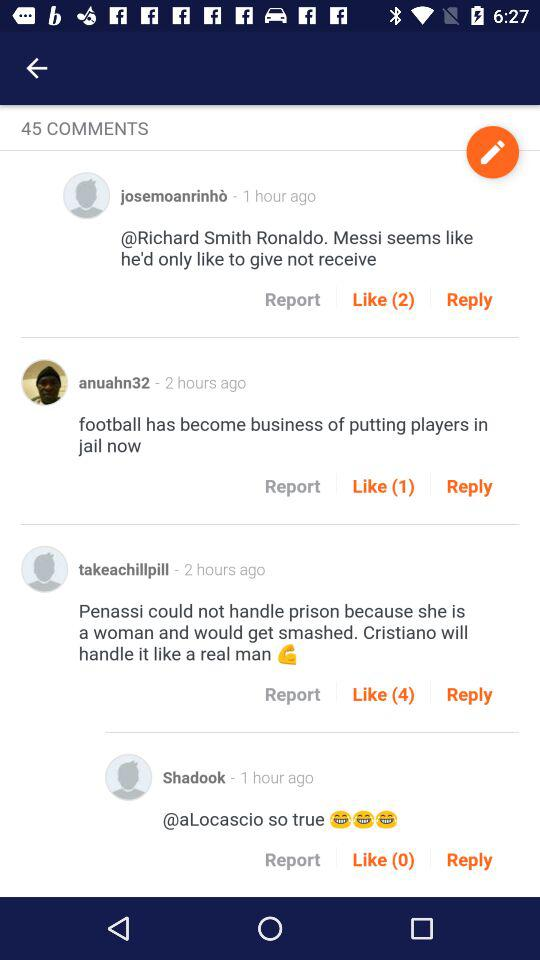When was the comment written by Shadook? The comment by Shadook was written 1 hour ago. 